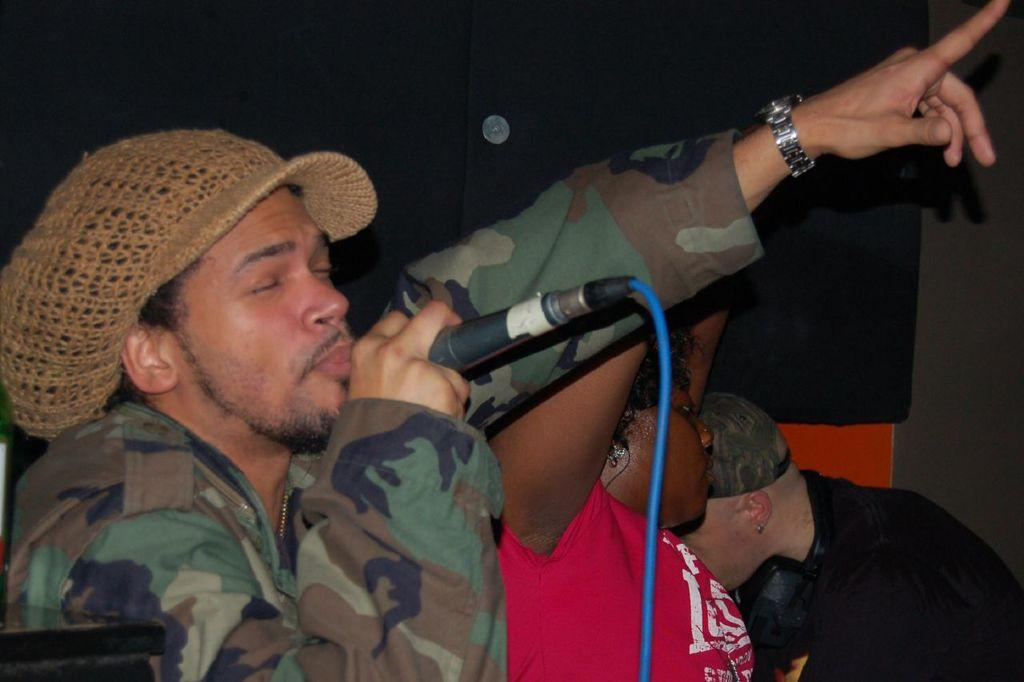How many people are in the image? There are three people in the image. Can you describe the position of the man in the image? The man is on the left side of the image. What is the man holding in his hand? The man is holding a microphone in his hand. What is the man doing in the image? The man is singing. How many ants can be seen crawling on the man's shoulder in the image? There are no ants visible on the man's shoulder in the image. What is the profit made by the man in the image? The image does not provide any information about the man's profit, as it focuses on his position and actions. 